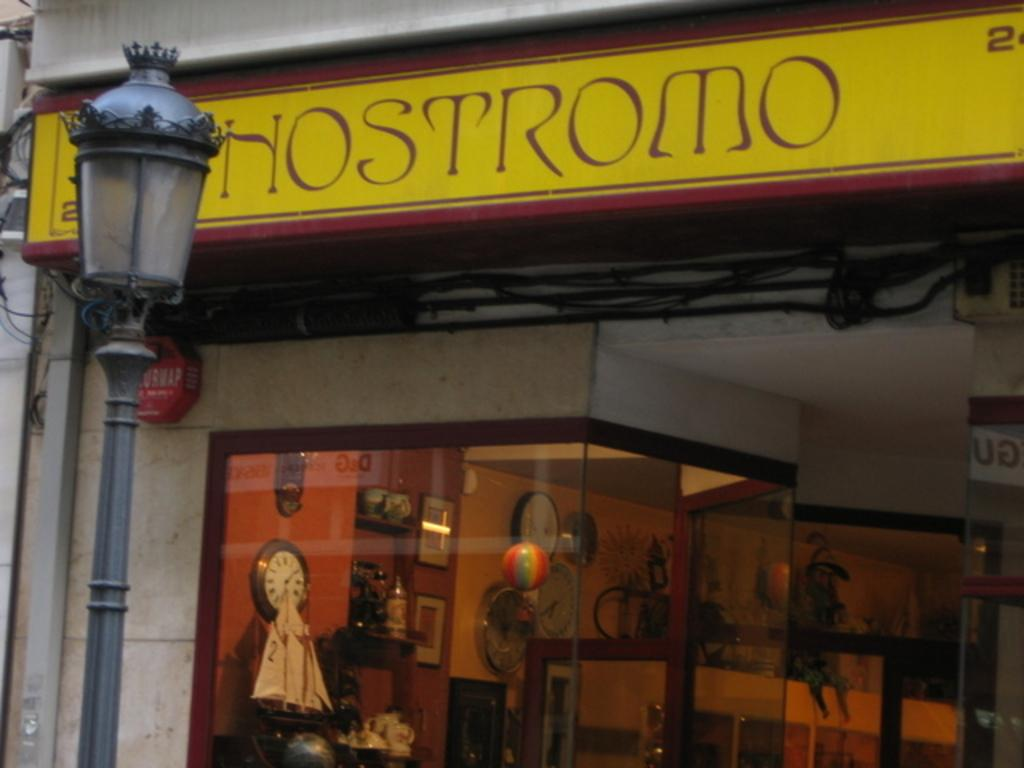<image>
Offer a succinct explanation of the picture presented. A yellow sign reading "hostromo" is above a boutique. 